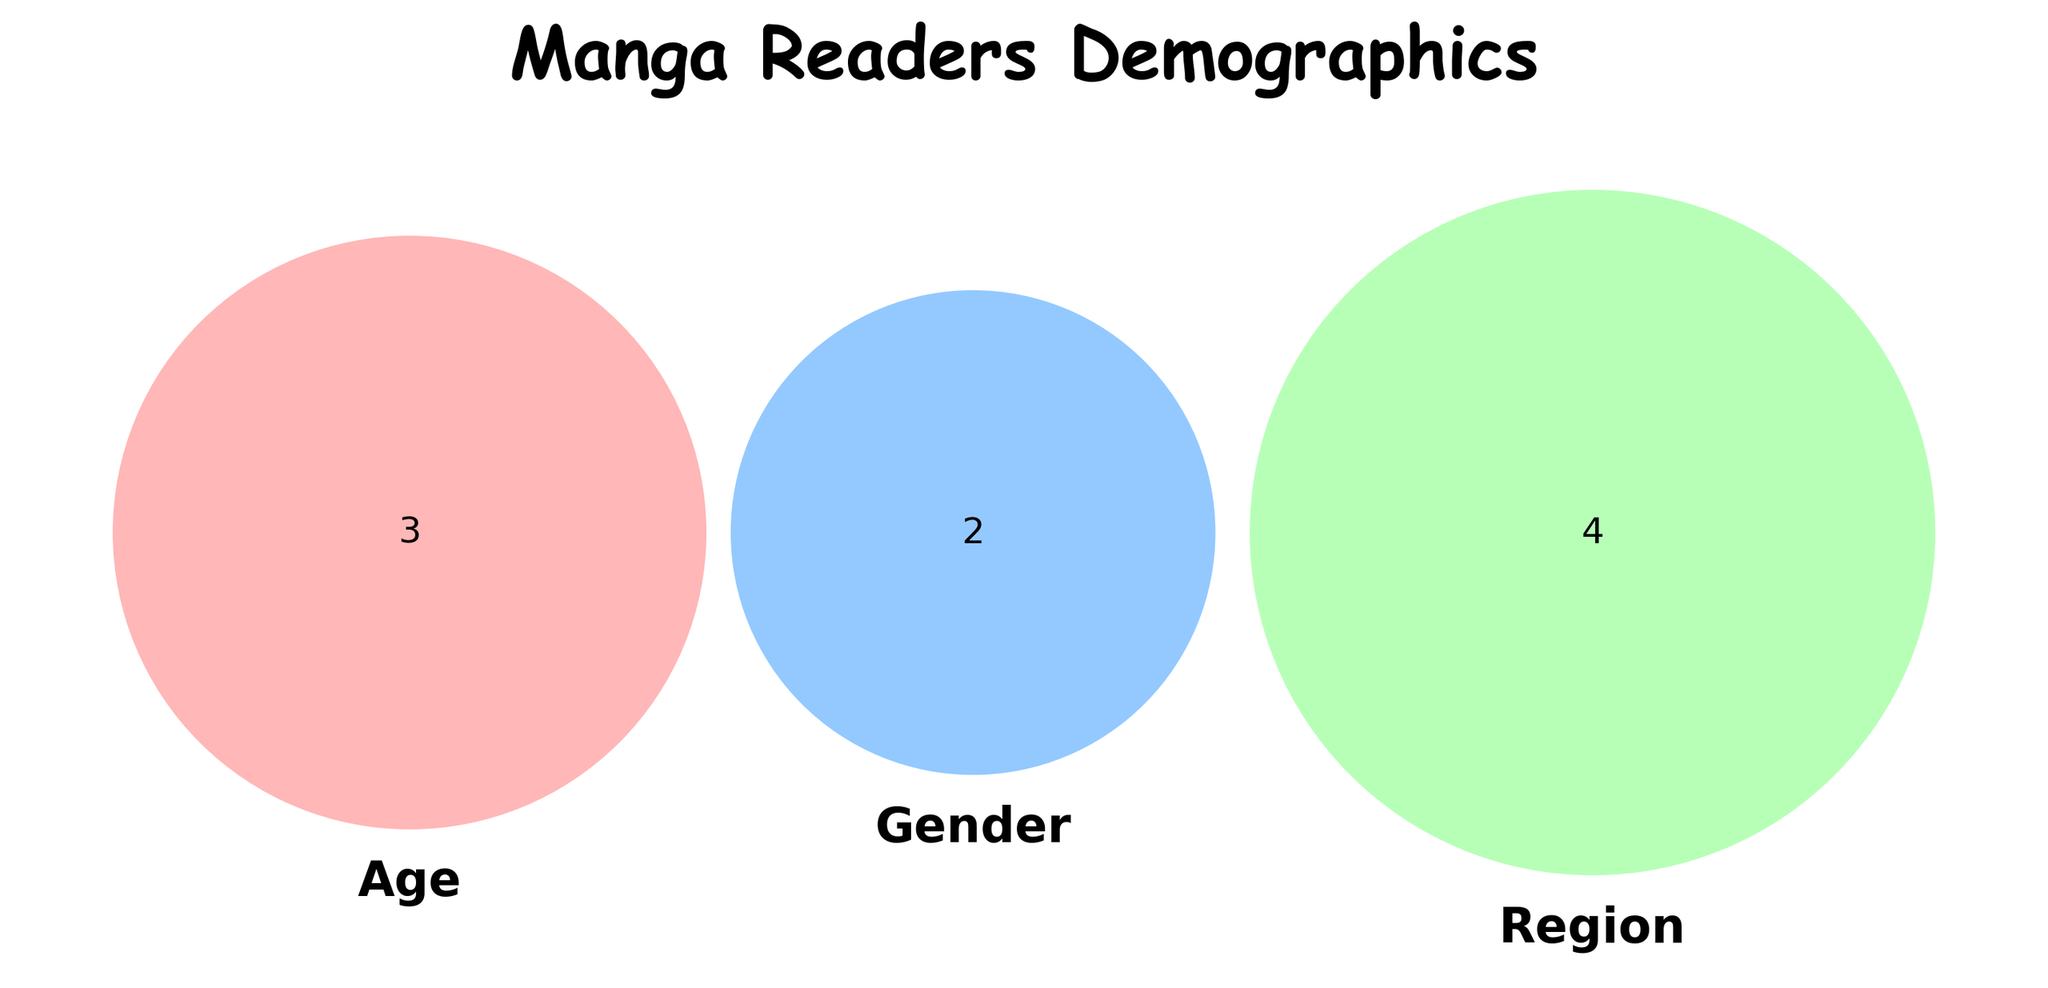What's the title of the Venn Diagram? The title is displayed at the top of the Venn Diagram with bold font. It reads "Manga Readers Demographics".
Answer: Manga Readers Demographics How many different sets are in the Venn Diagram? There are three sets in the Venn Diagram, one for Age, one for Gender, and one for Region.
Answer: 3 Which set has the color blue? The set labeled "Gender" is shown in blue.
Answer: Gender What are the unique combinations of Age, Gender, and Region present in the diagram? We need to identify each unique combination listed in the data (ex. Teens-Male-Japan). There are 9 unique combinations as per the data provided.
Answer: 9 What's the total number of Age groups represented? There are three different Age groups shown in the data: Teens, Adults, and Young Adults.
Answer: 3 Which Gender is represented more, Male or Female? Count the number of occurrences for each gender in the data. Males appear 5 times and Females appear 4 times. Males are represented more.
Answer: Male How many distinct regions are there? The data lists four distinct regions: Japan, North America, Europe, and Asia.
Answer: 4 Is there an overlap between Age and Region? Yes, the Venn Diagram shows overlaps between Age and Region circles, indicating that Age groups are spread across different Regions.
Answer: Yes Are there any overlaps between all three sets: Age, Gender, and Region? The central part of the Venn Diagram where all three circles intersect shows if there are any shared data points between Age, Gender, and Region.
Answer: Yes Which Age group has the most diversity in terms of Gender and Region? By examining the data, we can see which Age group appears with various combinations of Gender and Region. All Age groups are equally diverse in the data, each having multiple setup combinations (Teens 3, Adults 3, Young Adults 3).
Answer: Equal 